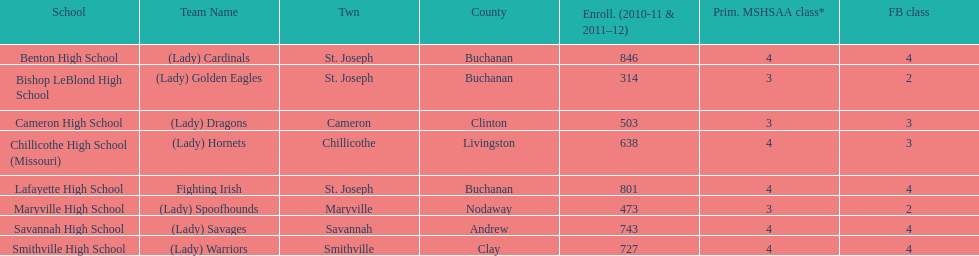Could you help me parse every detail presented in this table? {'header': ['School', 'Team Name', 'Twn', 'County', 'Enroll. (2010-11 & 2011–12)', 'Prim. MSHSAA class*', 'FB class'], 'rows': [['Benton High School', '(Lady) Cardinals', 'St. Joseph', 'Buchanan', '846', '4', '4'], ['Bishop LeBlond High School', '(Lady) Golden Eagles', 'St. Joseph', 'Buchanan', '314', '3', '2'], ['Cameron High School', '(Lady) Dragons', 'Cameron', 'Clinton', '503', '3', '3'], ['Chillicothe High School (Missouri)', '(Lady) Hornets', 'Chillicothe', 'Livingston', '638', '4', '3'], ['Lafayette High School', 'Fighting Irish', 'St. Joseph', 'Buchanan', '801', '4', '4'], ['Maryville High School', '(Lady) Spoofhounds', 'Maryville', 'Nodaway', '473', '3', '2'], ['Savannah High School', '(Lady) Savages', 'Savannah', 'Andrew', '743', '4', '4'], ['Smithville High School', '(Lady) Warriors', 'Smithville', 'Clay', '727', '4', '4']]} How many of the schools had at least 500 students enrolled in the 2010-2011 and 2011-2012 season? 6. 